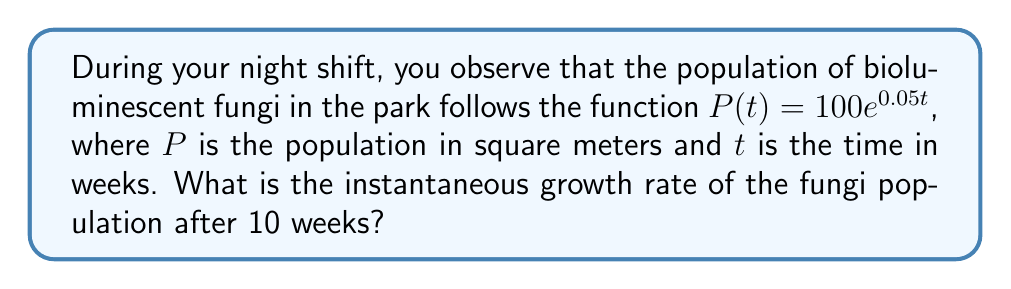Show me your answer to this math problem. To find the instantaneous growth rate, we need to calculate the derivative of the population function at $t = 10$ weeks. Let's follow these steps:

1) The given population function is:
   $P(t) = 100e^{0.05t}$

2) To find the growth rate, we need to differentiate $P(t)$ with respect to $t$:
   $$\frac{dP}{dt} = 100 \cdot 0.05e^{0.05t} = 5e^{0.05t}$$

3) This derivative represents the instantaneous growth rate at any time $t$.

4) To find the growth rate at 10 weeks, we substitute $t = 10$ into our derivative:
   $$\frac{dP}{dt}\bigg|_{t=10} = 5e^{0.05(10)} = 5e^{0.5}$$

5) Calculate the value:
   $$5e^{0.5} \approx 8.24$$

Therefore, the instantaneous growth rate of the bioluminescent fungi population after 10 weeks is approximately 8.24 square meters per week.
Answer: $5e^{0.5}$ sq m/week 